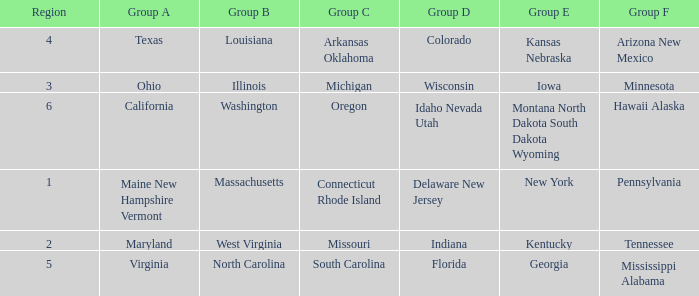What is the group A region with a region number of 2? Maryland. 